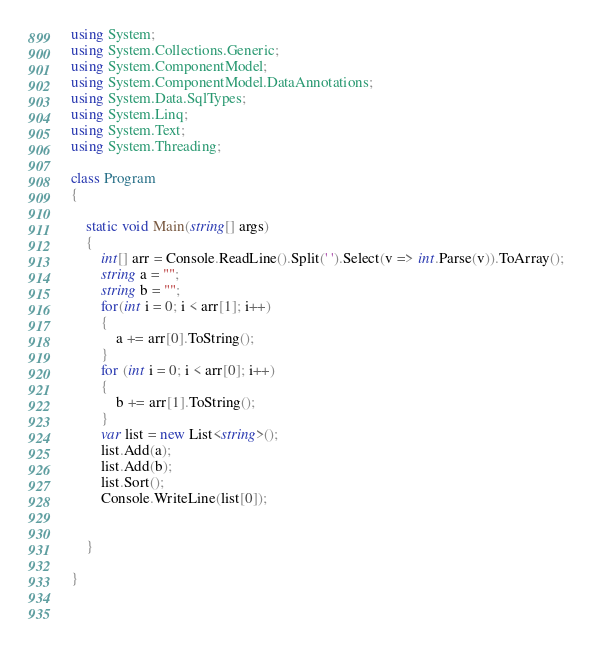Convert code to text. <code><loc_0><loc_0><loc_500><loc_500><_C#_>using System;
using System.Collections.Generic;
using System.ComponentModel;
using System.ComponentModel.DataAnnotations;
using System.Data.SqlTypes;
using System.Linq;
using System.Text;
using System.Threading;

class Program
{
    
    static void Main(string[] args)
    {
        int[] arr = Console.ReadLine().Split(' ').Select(v => int.Parse(v)).ToArray();
        string a = "";
        string b = "";
        for(int i = 0; i < arr[1]; i++)
        {
            a += arr[0].ToString();
        }
        for (int i = 0; i < arr[0]; i++)
        {
            b += arr[1].ToString();
        }
        var list = new List<string>();
        list.Add(a);
        list.Add(b);
        list.Sort();
        Console.WriteLine(list[0]);


    }

}

   </code> 